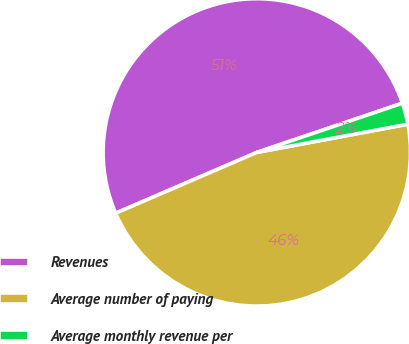<chart> <loc_0><loc_0><loc_500><loc_500><pie_chart><fcel>Revenues<fcel>Average number of paying<fcel>Average monthly revenue per<nl><fcel>51.28%<fcel>46.46%<fcel>2.25%<nl></chart> 